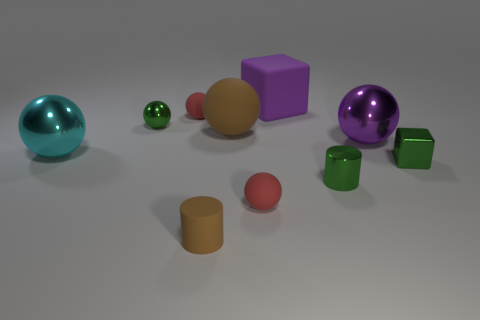Is there any other thing of the same color as the metal cube?
Your response must be concise. Yes. Are there fewer purple things that are to the left of the brown matte sphere than green metal cylinders?
Your response must be concise. Yes. What number of red things have the same size as the green metallic cube?
Keep it short and to the point. 2. What shape is the small rubber thing that is the same color as the large rubber ball?
Your response must be concise. Cylinder. The small red matte thing behind the green cylinder that is in front of the large sphere behind the big purple shiny thing is what shape?
Ensure brevity in your answer.  Sphere. What color is the tiny rubber thing that is behind the large brown rubber ball?
Keep it short and to the point. Red. How many objects are big purple matte things on the right side of the large cyan metal thing or balls that are left of the small shiny cylinder?
Ensure brevity in your answer.  6. What number of other tiny metal things have the same shape as the purple metal thing?
Provide a succinct answer. 1. What is the color of the block that is the same size as the brown matte ball?
Your response must be concise. Purple. There is a small metal thing that is behind the large thing that is left of the tiny red rubber object that is behind the cyan metallic object; what color is it?
Your answer should be very brief. Green. 